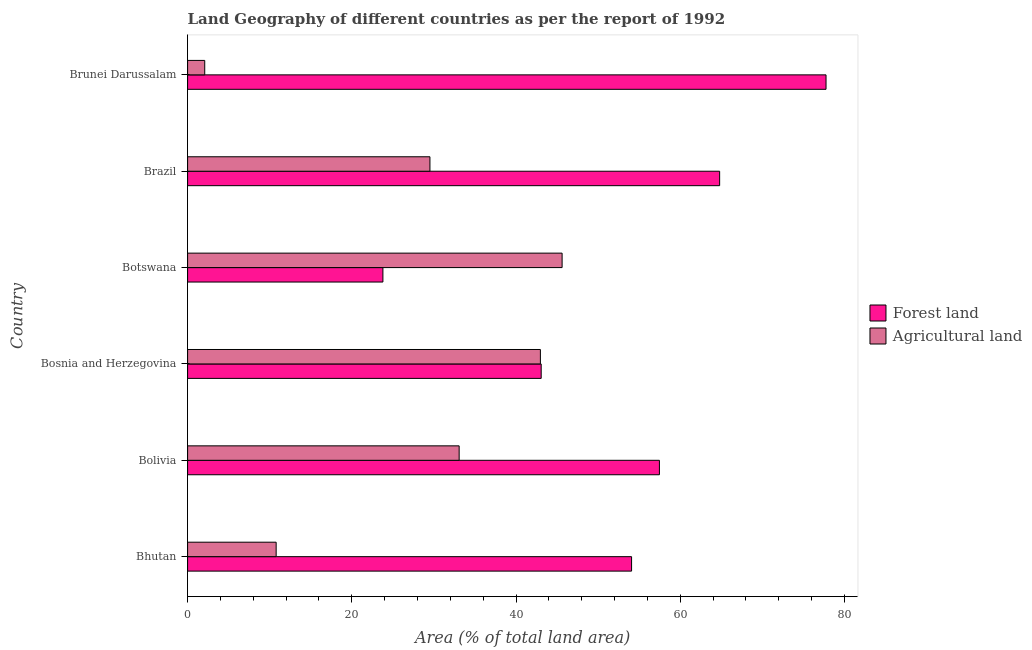How many different coloured bars are there?
Offer a very short reply. 2. How many groups of bars are there?
Offer a terse response. 6. Are the number of bars per tick equal to the number of legend labels?
Your answer should be compact. Yes. Are the number of bars on each tick of the Y-axis equal?
Make the answer very short. Yes. What is the label of the 1st group of bars from the top?
Keep it short and to the point. Brunei Darussalam. In how many cases, is the number of bars for a given country not equal to the number of legend labels?
Your answer should be very brief. 0. What is the percentage of land area under agriculture in Bosnia and Herzegovina?
Offer a very short reply. 42.97. Across all countries, what is the maximum percentage of land area under forests?
Ensure brevity in your answer.  77.76. Across all countries, what is the minimum percentage of land area under agriculture?
Offer a terse response. 2.09. In which country was the percentage of land area under agriculture maximum?
Offer a terse response. Botswana. In which country was the percentage of land area under forests minimum?
Offer a terse response. Botswana. What is the total percentage of land area under forests in the graph?
Offer a very short reply. 320.96. What is the difference between the percentage of land area under agriculture in Bhutan and that in Botswana?
Provide a short and direct response. -34.83. What is the difference between the percentage of land area under agriculture in Bosnia and Herzegovina and the percentage of land area under forests in Bolivia?
Your answer should be very brief. -14.5. What is the average percentage of land area under forests per country?
Make the answer very short. 53.49. What is the difference between the percentage of land area under forests and percentage of land area under agriculture in Bolivia?
Offer a terse response. 24.39. What is the ratio of the percentage of land area under agriculture in Bhutan to that in Bosnia and Herzegovina?
Your response must be concise. 0.25. What is the difference between the highest and the second highest percentage of land area under forests?
Provide a short and direct response. 12.96. What is the difference between the highest and the lowest percentage of land area under forests?
Make the answer very short. 53.97. Is the sum of the percentage of land area under forests in Bhutan and Brunei Darussalam greater than the maximum percentage of land area under agriculture across all countries?
Your response must be concise. Yes. What does the 1st bar from the top in Bhutan represents?
Make the answer very short. Agricultural land. What does the 1st bar from the bottom in Brunei Darussalam represents?
Your answer should be very brief. Forest land. How many bars are there?
Your answer should be very brief. 12. How many countries are there in the graph?
Your answer should be compact. 6. What is the difference between two consecutive major ticks on the X-axis?
Offer a very short reply. 20. Are the values on the major ticks of X-axis written in scientific E-notation?
Your response must be concise. No. Does the graph contain grids?
Make the answer very short. No. What is the title of the graph?
Give a very brief answer. Land Geography of different countries as per the report of 1992. What is the label or title of the X-axis?
Make the answer very short. Area (% of total land area). What is the Area (% of total land area) in Forest land in Bhutan?
Give a very brief answer. 54.08. What is the Area (% of total land area) of Agricultural land in Bhutan?
Your answer should be very brief. 10.79. What is the Area (% of total land area) in Forest land in Bolivia?
Offer a very short reply. 57.47. What is the Area (% of total land area) in Agricultural land in Bolivia?
Provide a short and direct response. 33.08. What is the Area (% of total land area) of Forest land in Bosnia and Herzegovina?
Provide a succinct answer. 43.07. What is the Area (% of total land area) in Agricultural land in Bosnia and Herzegovina?
Give a very brief answer. 42.97. What is the Area (% of total land area) of Forest land in Botswana?
Make the answer very short. 23.79. What is the Area (% of total land area) of Agricultural land in Botswana?
Offer a terse response. 45.61. What is the Area (% of total land area) in Forest land in Brazil?
Ensure brevity in your answer.  64.8. What is the Area (% of total land area) in Agricultural land in Brazil?
Keep it short and to the point. 29.52. What is the Area (% of total land area) in Forest land in Brunei Darussalam?
Provide a succinct answer. 77.76. What is the Area (% of total land area) of Agricultural land in Brunei Darussalam?
Offer a terse response. 2.09. Across all countries, what is the maximum Area (% of total land area) of Forest land?
Make the answer very short. 77.76. Across all countries, what is the maximum Area (% of total land area) in Agricultural land?
Keep it short and to the point. 45.61. Across all countries, what is the minimum Area (% of total land area) of Forest land?
Your response must be concise. 23.79. Across all countries, what is the minimum Area (% of total land area) of Agricultural land?
Ensure brevity in your answer.  2.09. What is the total Area (% of total land area) of Forest land in the graph?
Your response must be concise. 320.96. What is the total Area (% of total land area) of Agricultural land in the graph?
Keep it short and to the point. 164.05. What is the difference between the Area (% of total land area) in Forest land in Bhutan and that in Bolivia?
Provide a short and direct response. -3.39. What is the difference between the Area (% of total land area) of Agricultural land in Bhutan and that in Bolivia?
Your response must be concise. -22.29. What is the difference between the Area (% of total land area) of Forest land in Bhutan and that in Bosnia and Herzegovina?
Make the answer very short. 11.01. What is the difference between the Area (% of total land area) in Agricultural land in Bhutan and that in Bosnia and Herzegovina?
Your response must be concise. -32.18. What is the difference between the Area (% of total land area) in Forest land in Bhutan and that in Botswana?
Provide a succinct answer. 30.29. What is the difference between the Area (% of total land area) in Agricultural land in Bhutan and that in Botswana?
Your answer should be compact. -34.83. What is the difference between the Area (% of total land area) of Forest land in Bhutan and that in Brazil?
Ensure brevity in your answer.  -10.73. What is the difference between the Area (% of total land area) of Agricultural land in Bhutan and that in Brazil?
Your answer should be very brief. -18.73. What is the difference between the Area (% of total land area) of Forest land in Bhutan and that in Brunei Darussalam?
Keep it short and to the point. -23.69. What is the difference between the Area (% of total land area) of Agricultural land in Bhutan and that in Brunei Darussalam?
Make the answer very short. 8.7. What is the difference between the Area (% of total land area) in Forest land in Bolivia and that in Bosnia and Herzegovina?
Keep it short and to the point. 14.4. What is the difference between the Area (% of total land area) in Agricultural land in Bolivia and that in Bosnia and Herzegovina?
Your answer should be very brief. -9.89. What is the difference between the Area (% of total land area) in Forest land in Bolivia and that in Botswana?
Your response must be concise. 33.68. What is the difference between the Area (% of total land area) in Agricultural land in Bolivia and that in Botswana?
Make the answer very short. -12.54. What is the difference between the Area (% of total land area) of Forest land in Bolivia and that in Brazil?
Your answer should be very brief. -7.33. What is the difference between the Area (% of total land area) in Agricultural land in Bolivia and that in Brazil?
Offer a terse response. 3.56. What is the difference between the Area (% of total land area) in Forest land in Bolivia and that in Brunei Darussalam?
Provide a short and direct response. -20.29. What is the difference between the Area (% of total land area) in Agricultural land in Bolivia and that in Brunei Darussalam?
Ensure brevity in your answer.  30.99. What is the difference between the Area (% of total land area) in Forest land in Bosnia and Herzegovina and that in Botswana?
Provide a succinct answer. 19.28. What is the difference between the Area (% of total land area) of Agricultural land in Bosnia and Herzegovina and that in Botswana?
Your answer should be very brief. -2.65. What is the difference between the Area (% of total land area) of Forest land in Bosnia and Herzegovina and that in Brazil?
Ensure brevity in your answer.  -21.73. What is the difference between the Area (% of total land area) in Agricultural land in Bosnia and Herzegovina and that in Brazil?
Ensure brevity in your answer.  13.45. What is the difference between the Area (% of total land area) of Forest land in Bosnia and Herzegovina and that in Brunei Darussalam?
Your answer should be compact. -34.69. What is the difference between the Area (% of total land area) of Agricultural land in Bosnia and Herzegovina and that in Brunei Darussalam?
Provide a short and direct response. 40.88. What is the difference between the Area (% of total land area) of Forest land in Botswana and that in Brazil?
Your response must be concise. -41.01. What is the difference between the Area (% of total land area) in Agricultural land in Botswana and that in Brazil?
Keep it short and to the point. 16.1. What is the difference between the Area (% of total land area) in Forest land in Botswana and that in Brunei Darussalam?
Your answer should be very brief. -53.97. What is the difference between the Area (% of total land area) of Agricultural land in Botswana and that in Brunei Darussalam?
Your answer should be compact. 43.53. What is the difference between the Area (% of total land area) of Forest land in Brazil and that in Brunei Darussalam?
Provide a short and direct response. -12.96. What is the difference between the Area (% of total land area) of Agricultural land in Brazil and that in Brunei Darussalam?
Ensure brevity in your answer.  27.43. What is the difference between the Area (% of total land area) in Forest land in Bhutan and the Area (% of total land area) in Agricultural land in Bolivia?
Offer a very short reply. 21. What is the difference between the Area (% of total land area) in Forest land in Bhutan and the Area (% of total land area) in Agricultural land in Bosnia and Herzegovina?
Your answer should be compact. 11.11. What is the difference between the Area (% of total land area) of Forest land in Bhutan and the Area (% of total land area) of Agricultural land in Botswana?
Give a very brief answer. 8.46. What is the difference between the Area (% of total land area) in Forest land in Bhutan and the Area (% of total land area) in Agricultural land in Brazil?
Your answer should be very brief. 24.56. What is the difference between the Area (% of total land area) of Forest land in Bhutan and the Area (% of total land area) of Agricultural land in Brunei Darussalam?
Make the answer very short. 51.99. What is the difference between the Area (% of total land area) of Forest land in Bolivia and the Area (% of total land area) of Agricultural land in Bosnia and Herzegovina?
Make the answer very short. 14.5. What is the difference between the Area (% of total land area) of Forest land in Bolivia and the Area (% of total land area) of Agricultural land in Botswana?
Offer a terse response. 11.85. What is the difference between the Area (% of total land area) in Forest land in Bolivia and the Area (% of total land area) in Agricultural land in Brazil?
Your response must be concise. 27.95. What is the difference between the Area (% of total land area) in Forest land in Bolivia and the Area (% of total land area) in Agricultural land in Brunei Darussalam?
Your answer should be very brief. 55.38. What is the difference between the Area (% of total land area) of Forest land in Bosnia and Herzegovina and the Area (% of total land area) of Agricultural land in Botswana?
Ensure brevity in your answer.  -2.55. What is the difference between the Area (% of total land area) of Forest land in Bosnia and Herzegovina and the Area (% of total land area) of Agricultural land in Brazil?
Your answer should be very brief. 13.55. What is the difference between the Area (% of total land area) of Forest land in Bosnia and Herzegovina and the Area (% of total land area) of Agricultural land in Brunei Darussalam?
Provide a succinct answer. 40.98. What is the difference between the Area (% of total land area) of Forest land in Botswana and the Area (% of total land area) of Agricultural land in Brazil?
Give a very brief answer. -5.73. What is the difference between the Area (% of total land area) in Forest land in Botswana and the Area (% of total land area) in Agricultural land in Brunei Darussalam?
Your answer should be very brief. 21.7. What is the difference between the Area (% of total land area) in Forest land in Brazil and the Area (% of total land area) in Agricultural land in Brunei Darussalam?
Give a very brief answer. 62.71. What is the average Area (% of total land area) of Forest land per country?
Your response must be concise. 53.49. What is the average Area (% of total land area) of Agricultural land per country?
Offer a very short reply. 27.34. What is the difference between the Area (% of total land area) in Forest land and Area (% of total land area) in Agricultural land in Bhutan?
Your answer should be compact. 43.29. What is the difference between the Area (% of total land area) of Forest land and Area (% of total land area) of Agricultural land in Bolivia?
Offer a terse response. 24.39. What is the difference between the Area (% of total land area) in Forest land and Area (% of total land area) in Agricultural land in Bosnia and Herzegovina?
Keep it short and to the point. 0.1. What is the difference between the Area (% of total land area) in Forest land and Area (% of total land area) in Agricultural land in Botswana?
Your answer should be very brief. -21.83. What is the difference between the Area (% of total land area) of Forest land and Area (% of total land area) of Agricultural land in Brazil?
Your answer should be compact. 35.28. What is the difference between the Area (% of total land area) of Forest land and Area (% of total land area) of Agricultural land in Brunei Darussalam?
Ensure brevity in your answer.  75.67. What is the ratio of the Area (% of total land area) of Forest land in Bhutan to that in Bolivia?
Your answer should be compact. 0.94. What is the ratio of the Area (% of total land area) of Agricultural land in Bhutan to that in Bolivia?
Keep it short and to the point. 0.33. What is the ratio of the Area (% of total land area) of Forest land in Bhutan to that in Bosnia and Herzegovina?
Your response must be concise. 1.26. What is the ratio of the Area (% of total land area) of Agricultural land in Bhutan to that in Bosnia and Herzegovina?
Give a very brief answer. 0.25. What is the ratio of the Area (% of total land area) in Forest land in Bhutan to that in Botswana?
Ensure brevity in your answer.  2.27. What is the ratio of the Area (% of total land area) in Agricultural land in Bhutan to that in Botswana?
Make the answer very short. 0.24. What is the ratio of the Area (% of total land area) of Forest land in Bhutan to that in Brazil?
Provide a short and direct response. 0.83. What is the ratio of the Area (% of total land area) of Agricultural land in Bhutan to that in Brazil?
Provide a short and direct response. 0.37. What is the ratio of the Area (% of total land area) in Forest land in Bhutan to that in Brunei Darussalam?
Your answer should be very brief. 0.7. What is the ratio of the Area (% of total land area) of Agricultural land in Bhutan to that in Brunei Darussalam?
Offer a very short reply. 5.17. What is the ratio of the Area (% of total land area) in Forest land in Bolivia to that in Bosnia and Herzegovina?
Your answer should be compact. 1.33. What is the ratio of the Area (% of total land area) of Agricultural land in Bolivia to that in Bosnia and Herzegovina?
Provide a short and direct response. 0.77. What is the ratio of the Area (% of total land area) in Forest land in Bolivia to that in Botswana?
Give a very brief answer. 2.42. What is the ratio of the Area (% of total land area) of Agricultural land in Bolivia to that in Botswana?
Offer a very short reply. 0.73. What is the ratio of the Area (% of total land area) of Forest land in Bolivia to that in Brazil?
Offer a terse response. 0.89. What is the ratio of the Area (% of total land area) of Agricultural land in Bolivia to that in Brazil?
Ensure brevity in your answer.  1.12. What is the ratio of the Area (% of total land area) in Forest land in Bolivia to that in Brunei Darussalam?
Your response must be concise. 0.74. What is the ratio of the Area (% of total land area) of Agricultural land in Bolivia to that in Brunei Darussalam?
Keep it short and to the point. 15.85. What is the ratio of the Area (% of total land area) of Forest land in Bosnia and Herzegovina to that in Botswana?
Make the answer very short. 1.81. What is the ratio of the Area (% of total land area) in Agricultural land in Bosnia and Herzegovina to that in Botswana?
Give a very brief answer. 0.94. What is the ratio of the Area (% of total land area) in Forest land in Bosnia and Herzegovina to that in Brazil?
Ensure brevity in your answer.  0.66. What is the ratio of the Area (% of total land area) in Agricultural land in Bosnia and Herzegovina to that in Brazil?
Your answer should be very brief. 1.46. What is the ratio of the Area (% of total land area) in Forest land in Bosnia and Herzegovina to that in Brunei Darussalam?
Your response must be concise. 0.55. What is the ratio of the Area (% of total land area) of Agricultural land in Bosnia and Herzegovina to that in Brunei Darussalam?
Provide a succinct answer. 20.59. What is the ratio of the Area (% of total land area) in Forest land in Botswana to that in Brazil?
Your answer should be compact. 0.37. What is the ratio of the Area (% of total land area) in Agricultural land in Botswana to that in Brazil?
Provide a succinct answer. 1.55. What is the ratio of the Area (% of total land area) in Forest land in Botswana to that in Brunei Darussalam?
Your answer should be compact. 0.31. What is the ratio of the Area (% of total land area) in Agricultural land in Botswana to that in Brunei Darussalam?
Your response must be concise. 21.85. What is the ratio of the Area (% of total land area) of Forest land in Brazil to that in Brunei Darussalam?
Keep it short and to the point. 0.83. What is the ratio of the Area (% of total land area) in Agricultural land in Brazil to that in Brunei Darussalam?
Your answer should be compact. 14.14. What is the difference between the highest and the second highest Area (% of total land area) of Forest land?
Your answer should be compact. 12.96. What is the difference between the highest and the second highest Area (% of total land area) of Agricultural land?
Provide a short and direct response. 2.65. What is the difference between the highest and the lowest Area (% of total land area) of Forest land?
Provide a succinct answer. 53.97. What is the difference between the highest and the lowest Area (% of total land area) in Agricultural land?
Your response must be concise. 43.53. 